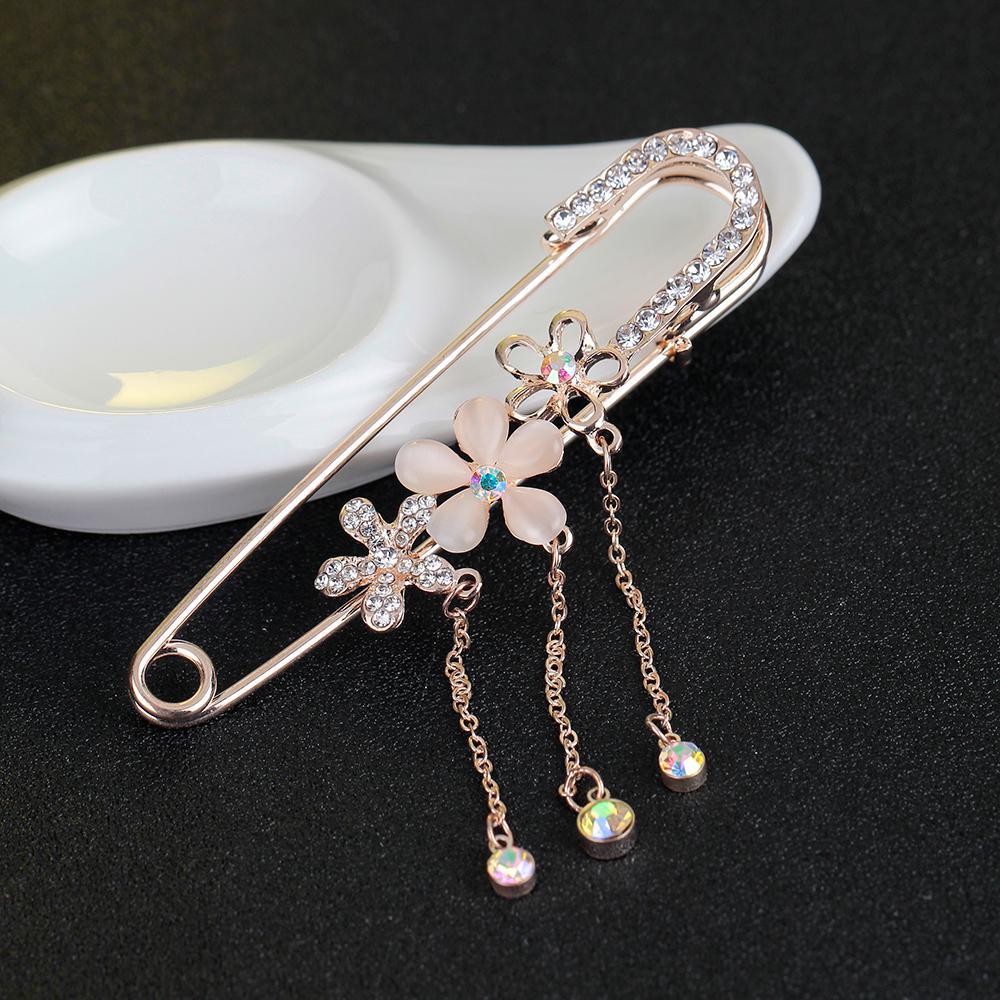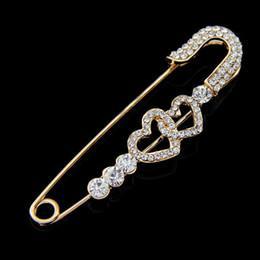The first image is the image on the left, the second image is the image on the right. For the images displayed, is the sentence "1 safety pin is in front of a white dish." factually correct? Answer yes or no. Yes. 